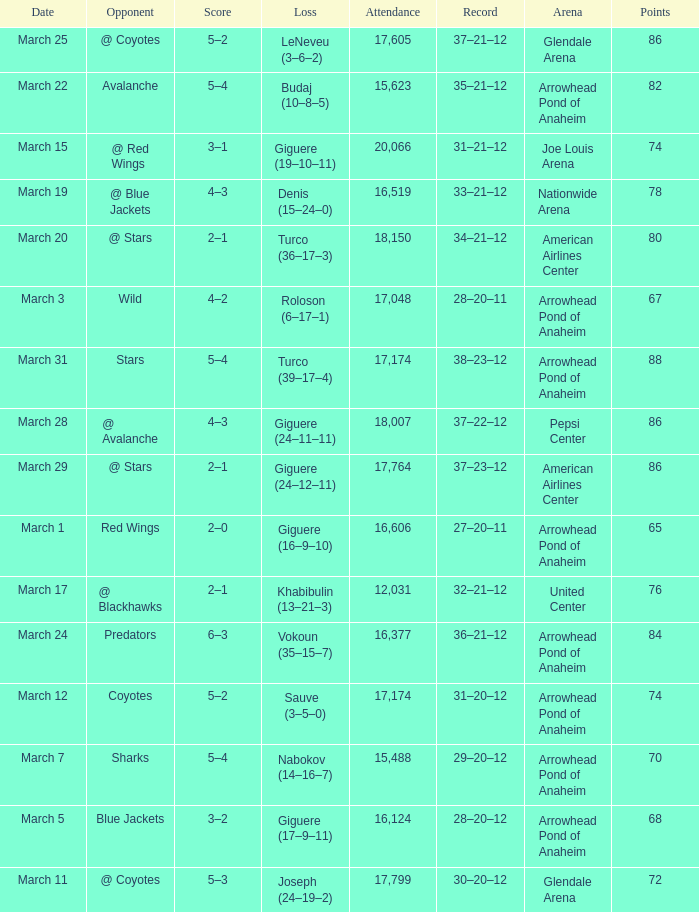What is the Attendance of the game with a Record of 37–21–12 and less than 86 Points? None. 